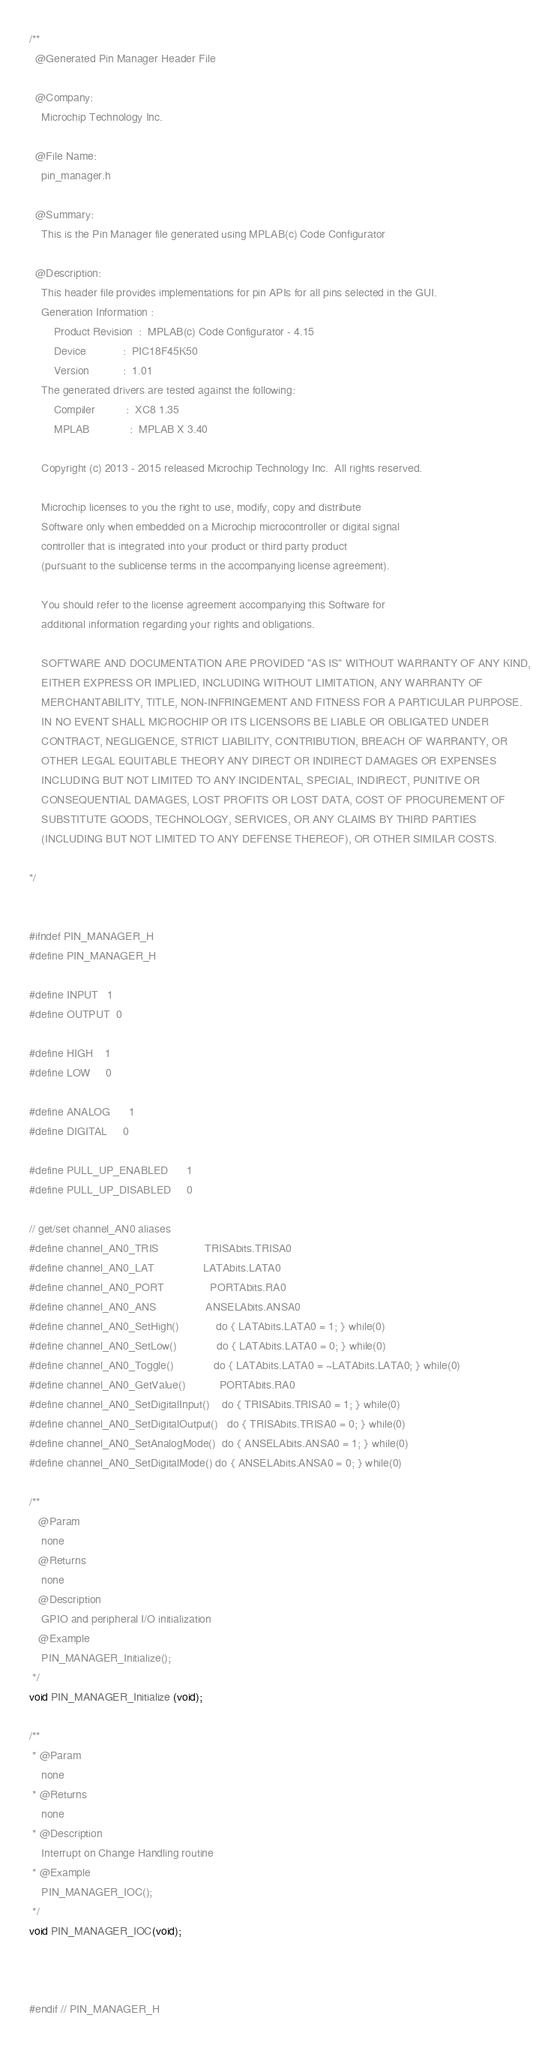<code> <loc_0><loc_0><loc_500><loc_500><_C_>/**
  @Generated Pin Manager Header File

  @Company:
    Microchip Technology Inc.

  @File Name:
    pin_manager.h

  @Summary:
    This is the Pin Manager file generated using MPLAB(c) Code Configurator

  @Description:
    This header file provides implementations for pin APIs for all pins selected in the GUI.
    Generation Information :
        Product Revision  :  MPLAB(c) Code Configurator - 4.15
        Device            :  PIC18F45K50
        Version           :  1.01
    The generated drivers are tested against the following:
        Compiler          :  XC8 1.35
        MPLAB             :  MPLAB X 3.40

    Copyright (c) 2013 - 2015 released Microchip Technology Inc.  All rights reserved.

    Microchip licenses to you the right to use, modify, copy and distribute
    Software only when embedded on a Microchip microcontroller or digital signal
    controller that is integrated into your product or third party product
    (pursuant to the sublicense terms in the accompanying license agreement).

    You should refer to the license agreement accompanying this Software for
    additional information regarding your rights and obligations.

    SOFTWARE AND DOCUMENTATION ARE PROVIDED "AS IS" WITHOUT WARRANTY OF ANY KIND,
    EITHER EXPRESS OR IMPLIED, INCLUDING WITHOUT LIMITATION, ANY WARRANTY OF
    MERCHANTABILITY, TITLE, NON-INFRINGEMENT AND FITNESS FOR A PARTICULAR PURPOSE.
    IN NO EVENT SHALL MICROCHIP OR ITS LICENSORS BE LIABLE OR OBLIGATED UNDER
    CONTRACT, NEGLIGENCE, STRICT LIABILITY, CONTRIBUTION, BREACH OF WARRANTY, OR
    OTHER LEGAL EQUITABLE THEORY ANY DIRECT OR INDIRECT DAMAGES OR EXPENSES
    INCLUDING BUT NOT LIMITED TO ANY INCIDENTAL, SPECIAL, INDIRECT, PUNITIVE OR
    CONSEQUENTIAL DAMAGES, LOST PROFITS OR LOST DATA, COST OF PROCUREMENT OF
    SUBSTITUTE GOODS, TECHNOLOGY, SERVICES, OR ANY CLAIMS BY THIRD PARTIES
    (INCLUDING BUT NOT LIMITED TO ANY DEFENSE THEREOF), OR OTHER SIMILAR COSTS.

*/


#ifndef PIN_MANAGER_H
#define PIN_MANAGER_H

#define INPUT   1
#define OUTPUT  0

#define HIGH    1
#define LOW     0

#define ANALOG      1
#define DIGITAL     0

#define PULL_UP_ENABLED      1
#define PULL_UP_DISABLED     0

// get/set channel_AN0 aliases
#define channel_AN0_TRIS               TRISAbits.TRISA0
#define channel_AN0_LAT                LATAbits.LATA0
#define channel_AN0_PORT               PORTAbits.RA0
#define channel_AN0_ANS                ANSELAbits.ANSA0
#define channel_AN0_SetHigh()            do { LATAbits.LATA0 = 1; } while(0)
#define channel_AN0_SetLow()             do { LATAbits.LATA0 = 0; } while(0)
#define channel_AN0_Toggle()             do { LATAbits.LATA0 = ~LATAbits.LATA0; } while(0)
#define channel_AN0_GetValue()           PORTAbits.RA0
#define channel_AN0_SetDigitalInput()    do { TRISAbits.TRISA0 = 1; } while(0)
#define channel_AN0_SetDigitalOutput()   do { TRISAbits.TRISA0 = 0; } while(0)
#define channel_AN0_SetAnalogMode()  do { ANSELAbits.ANSA0 = 1; } while(0)
#define channel_AN0_SetDigitalMode() do { ANSELAbits.ANSA0 = 0; } while(0)

/**
   @Param
    none
   @Returns
    none
   @Description
    GPIO and peripheral I/O initialization
   @Example
    PIN_MANAGER_Initialize();
 */
void PIN_MANAGER_Initialize (void);

/**
 * @Param
    none
 * @Returns
    none
 * @Description
    Interrupt on Change Handling routine
 * @Example
    PIN_MANAGER_IOC();
 */
void PIN_MANAGER_IOC(void);



#endif // PIN_MANAGER_H</code> 